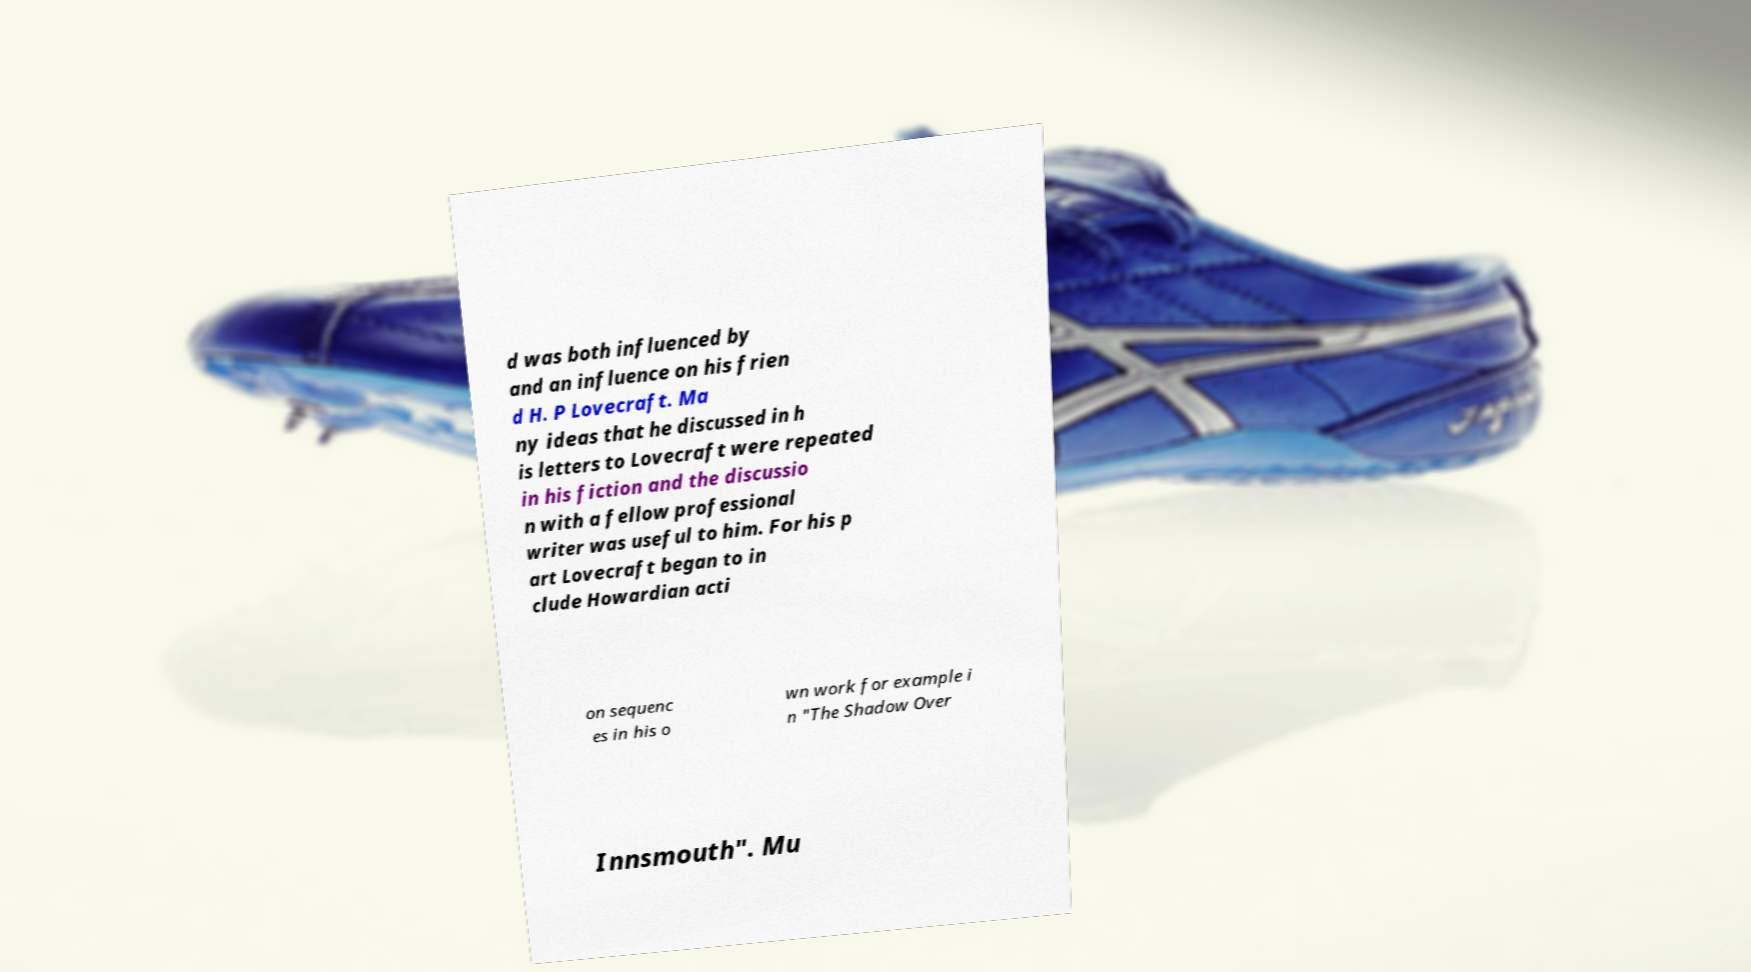There's text embedded in this image that I need extracted. Can you transcribe it verbatim? d was both influenced by and an influence on his frien d H. P Lovecraft. Ma ny ideas that he discussed in h is letters to Lovecraft were repeated in his fiction and the discussio n with a fellow professional writer was useful to him. For his p art Lovecraft began to in clude Howardian acti on sequenc es in his o wn work for example i n "The Shadow Over Innsmouth". Mu 